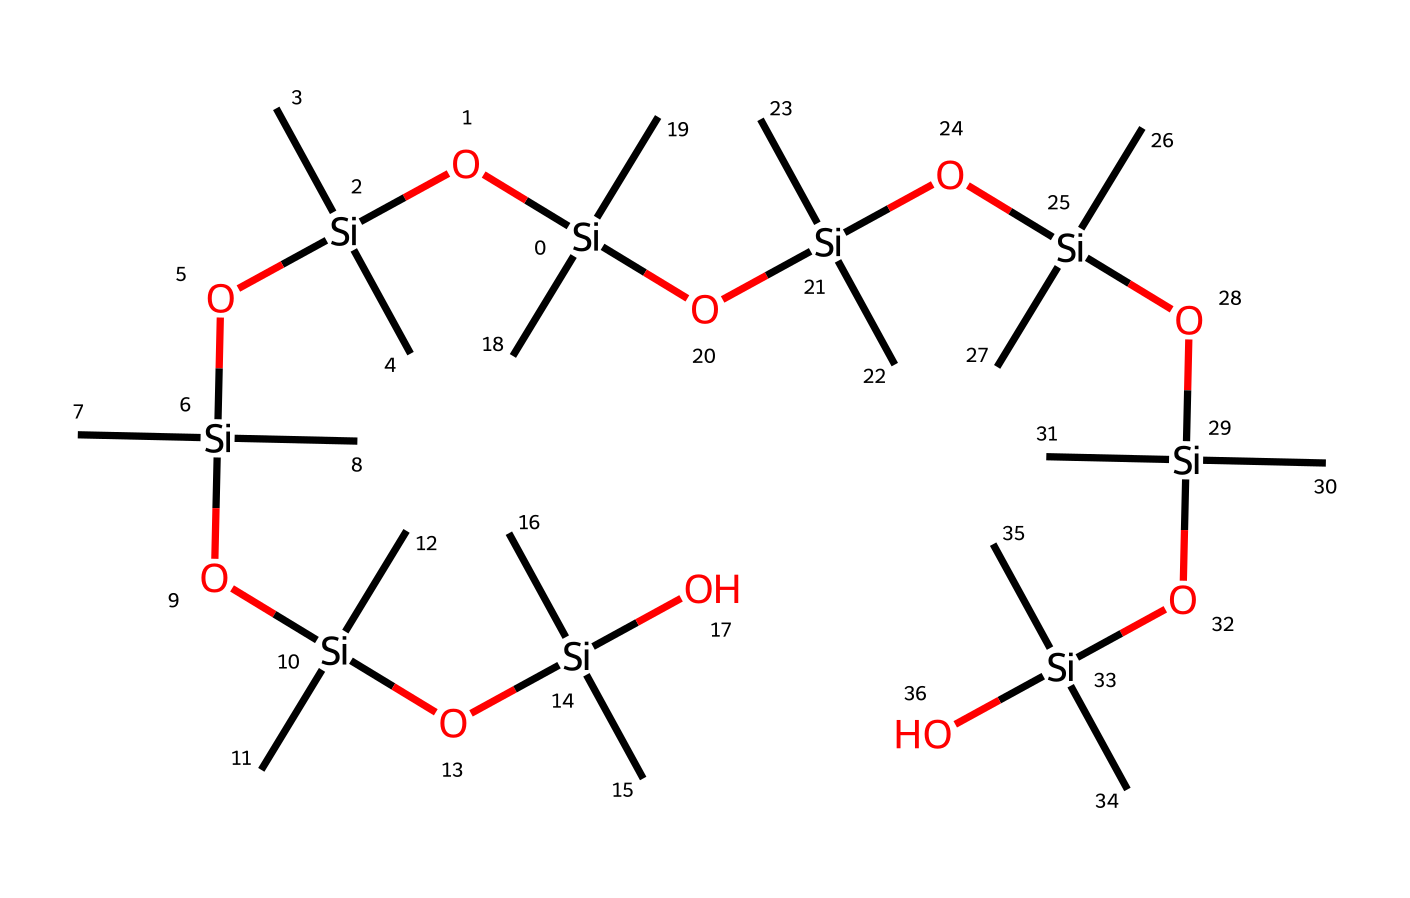What is the primary element in this chemical structure? The chemical structure of this compound prominently features silicon atoms as the backbone in the SMILES representation. Therefore, the primary element is silicon.
Answer: silicon How many oxygen atoms are present in the structure? By analyzing the SMILES representation, we can see that there are several instances of the letter 'O'. Counting them reveals there are a total of eight oxygen atoms present in the structure.
Answer: eight What type of functional groups can be identified in this chemical? The structure contains siloxane (Si-O bonds) along with terminal hydroxyl groups (Si-OH) due to the presence of oxygen and silicon atoms. This indicates the molecule has siloxane functional groups and hydroxyl functionalities.
Answer: siloxane and hydroxyl How many silicon atoms does the structure have? Analyzing the SMILES representation, we see multiple instances of the silicon atom denoted as 'Si'. Counting the 'Si' reveals that there are nine silicon atoms in the entire structure.
Answer: nine What is the general classification of this chemical compound? Given the prominent presence of silicon and its organic nature, this compound falls into the category of organosilicon compounds due to its silicon-carbon connections along with functional groups.
Answer: organosilicon How does the connectivity in this chemical signify its use in sealants? The interconnected siloxane bonds (Si-O) and the presence of organic side groups indicate high flexibility, water resistance, and adhesion properties, making it suitable for sealant applications.
Answer: high flexibility and adhesion 